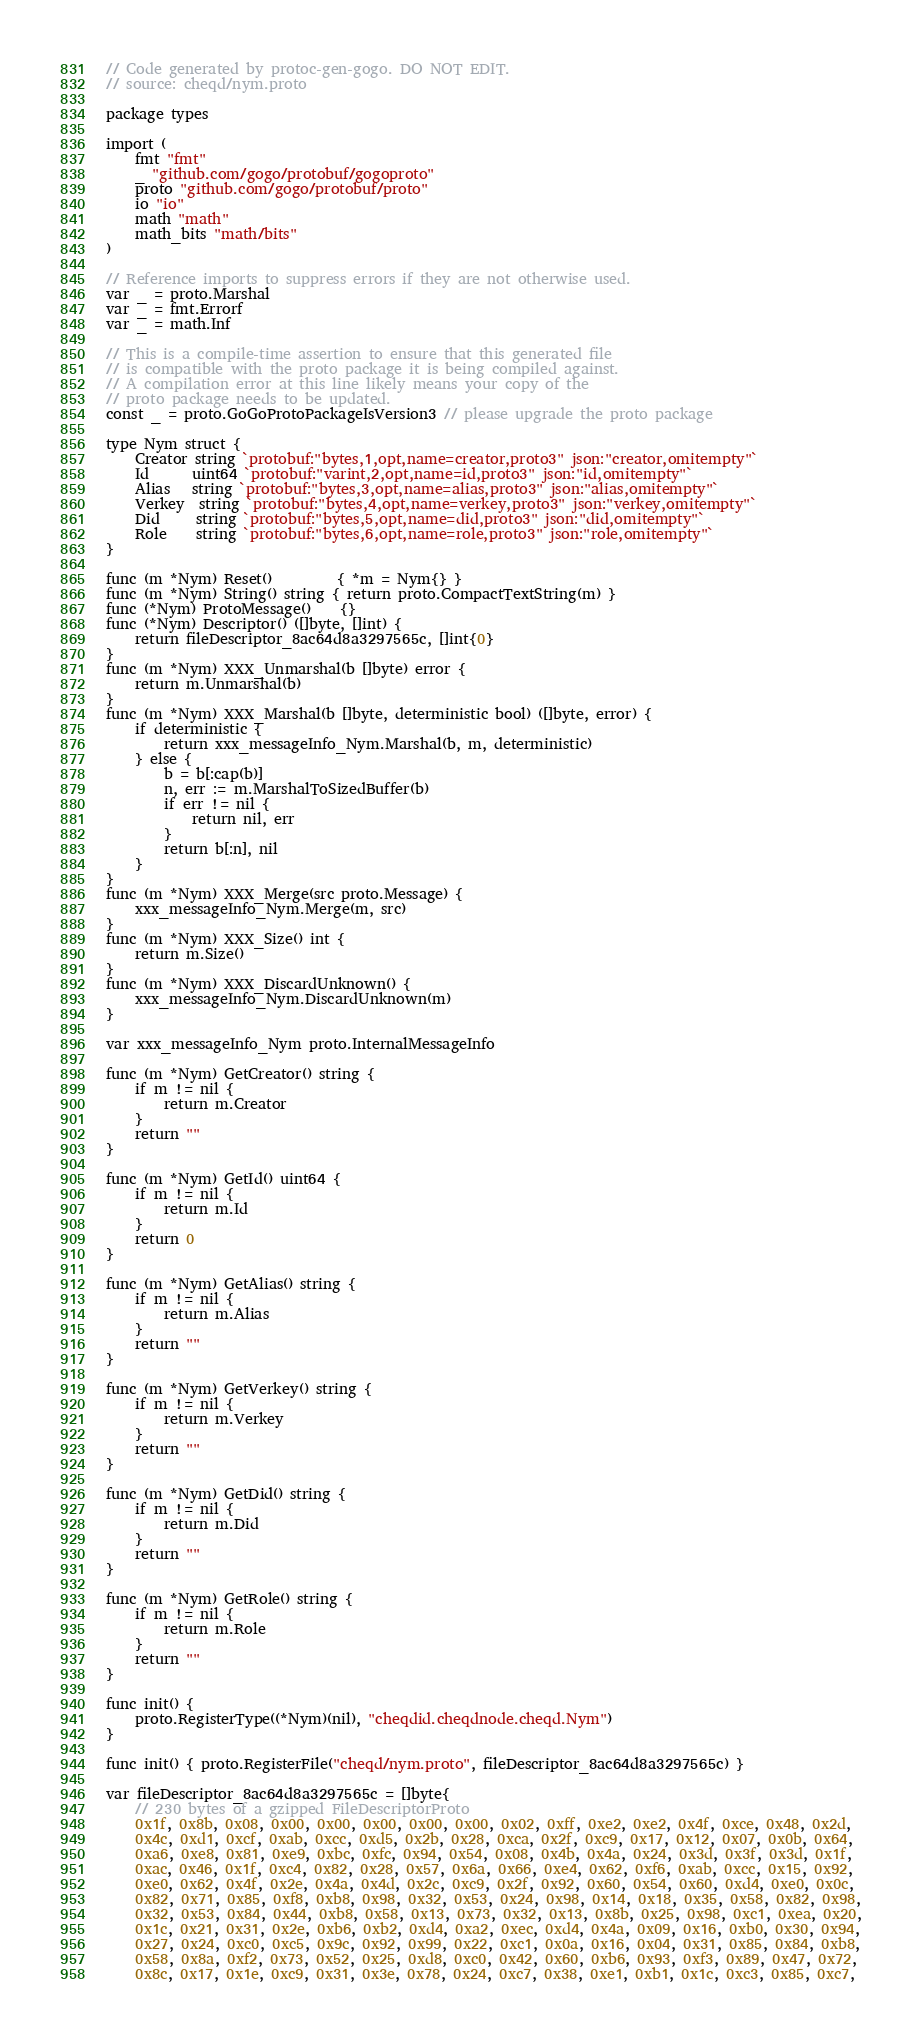<code> <loc_0><loc_0><loc_500><loc_500><_Go_>// Code generated by protoc-gen-gogo. DO NOT EDIT.
// source: cheqd/nym.proto

package types

import (
	fmt "fmt"
	_ "github.com/gogo/protobuf/gogoproto"
	proto "github.com/gogo/protobuf/proto"
	io "io"
	math "math"
	math_bits "math/bits"
)

// Reference imports to suppress errors if they are not otherwise used.
var _ = proto.Marshal
var _ = fmt.Errorf
var _ = math.Inf

// This is a compile-time assertion to ensure that this generated file
// is compatible with the proto package it is being compiled against.
// A compilation error at this line likely means your copy of the
// proto package needs to be updated.
const _ = proto.GoGoProtoPackageIsVersion3 // please upgrade the proto package

type Nym struct {
	Creator string `protobuf:"bytes,1,opt,name=creator,proto3" json:"creator,omitempty"`
	Id      uint64 `protobuf:"varint,2,opt,name=id,proto3" json:"id,omitempty"`
	Alias   string `protobuf:"bytes,3,opt,name=alias,proto3" json:"alias,omitempty"`
	Verkey  string `protobuf:"bytes,4,opt,name=verkey,proto3" json:"verkey,omitempty"`
	Did     string `protobuf:"bytes,5,opt,name=did,proto3" json:"did,omitempty"`
	Role    string `protobuf:"bytes,6,opt,name=role,proto3" json:"role,omitempty"`
}

func (m *Nym) Reset()         { *m = Nym{} }
func (m *Nym) String() string { return proto.CompactTextString(m) }
func (*Nym) ProtoMessage()    {}
func (*Nym) Descriptor() ([]byte, []int) {
	return fileDescriptor_8ac64d8a3297565c, []int{0}
}
func (m *Nym) XXX_Unmarshal(b []byte) error {
	return m.Unmarshal(b)
}
func (m *Nym) XXX_Marshal(b []byte, deterministic bool) ([]byte, error) {
	if deterministic {
		return xxx_messageInfo_Nym.Marshal(b, m, deterministic)
	} else {
		b = b[:cap(b)]
		n, err := m.MarshalToSizedBuffer(b)
		if err != nil {
			return nil, err
		}
		return b[:n], nil
	}
}
func (m *Nym) XXX_Merge(src proto.Message) {
	xxx_messageInfo_Nym.Merge(m, src)
}
func (m *Nym) XXX_Size() int {
	return m.Size()
}
func (m *Nym) XXX_DiscardUnknown() {
	xxx_messageInfo_Nym.DiscardUnknown(m)
}

var xxx_messageInfo_Nym proto.InternalMessageInfo

func (m *Nym) GetCreator() string {
	if m != nil {
		return m.Creator
	}
	return ""
}

func (m *Nym) GetId() uint64 {
	if m != nil {
		return m.Id
	}
	return 0
}

func (m *Nym) GetAlias() string {
	if m != nil {
		return m.Alias
	}
	return ""
}

func (m *Nym) GetVerkey() string {
	if m != nil {
		return m.Verkey
	}
	return ""
}

func (m *Nym) GetDid() string {
	if m != nil {
		return m.Did
	}
	return ""
}

func (m *Nym) GetRole() string {
	if m != nil {
		return m.Role
	}
	return ""
}

func init() {
	proto.RegisterType((*Nym)(nil), "cheqdid.cheqdnode.cheqd.Nym")
}

func init() { proto.RegisterFile("cheqd/nym.proto", fileDescriptor_8ac64d8a3297565c) }

var fileDescriptor_8ac64d8a3297565c = []byte{
	// 230 bytes of a gzipped FileDescriptorProto
	0x1f, 0x8b, 0x08, 0x00, 0x00, 0x00, 0x00, 0x00, 0x02, 0xff, 0xe2, 0xe2, 0x4f, 0xce, 0x48, 0x2d,
	0x4c, 0xd1, 0xcf, 0xab, 0xcc, 0xd5, 0x2b, 0x28, 0xca, 0x2f, 0xc9, 0x17, 0x12, 0x07, 0x0b, 0x64,
	0xa6, 0xe8, 0x81, 0xe9, 0xbc, 0xfc, 0x94, 0x54, 0x08, 0x4b, 0x4a, 0x24, 0x3d, 0x3f, 0x3d, 0x1f,
	0xac, 0x46, 0x1f, 0xc4, 0x82, 0x28, 0x57, 0x6a, 0x66, 0xe4, 0x62, 0xf6, 0xab, 0xcc, 0x15, 0x92,
	0xe0, 0x62, 0x4f, 0x2e, 0x4a, 0x4d, 0x2c, 0xc9, 0x2f, 0x92, 0x60, 0x54, 0x60, 0xd4, 0xe0, 0x0c,
	0x82, 0x71, 0x85, 0xf8, 0xb8, 0x98, 0x32, 0x53, 0x24, 0x98, 0x14, 0x18, 0x35, 0x58, 0x82, 0x98,
	0x32, 0x53, 0x84, 0x44, 0xb8, 0x58, 0x13, 0x73, 0x32, 0x13, 0x8b, 0x25, 0x98, 0xc1, 0xea, 0x20,
	0x1c, 0x21, 0x31, 0x2e, 0xb6, 0xb2, 0xd4, 0xa2, 0xec, 0xd4, 0x4a, 0x09, 0x16, 0xb0, 0x30, 0x94,
	0x27, 0x24, 0xc0, 0xc5, 0x9c, 0x92, 0x99, 0x22, 0xc1, 0x0a, 0x16, 0x04, 0x31, 0x85, 0x84, 0xb8,
	0x58, 0x8a, 0xf2, 0x73, 0x52, 0x25, 0xd8, 0xc0, 0x42, 0x60, 0xb6, 0x93, 0xf3, 0x89, 0x47, 0x72,
	0x8c, 0x17, 0x1e, 0xc9, 0x31, 0x3e, 0x78, 0x24, 0xc7, 0x38, 0xe1, 0xb1, 0x1c, 0xc3, 0x85, 0xc7,</code> 